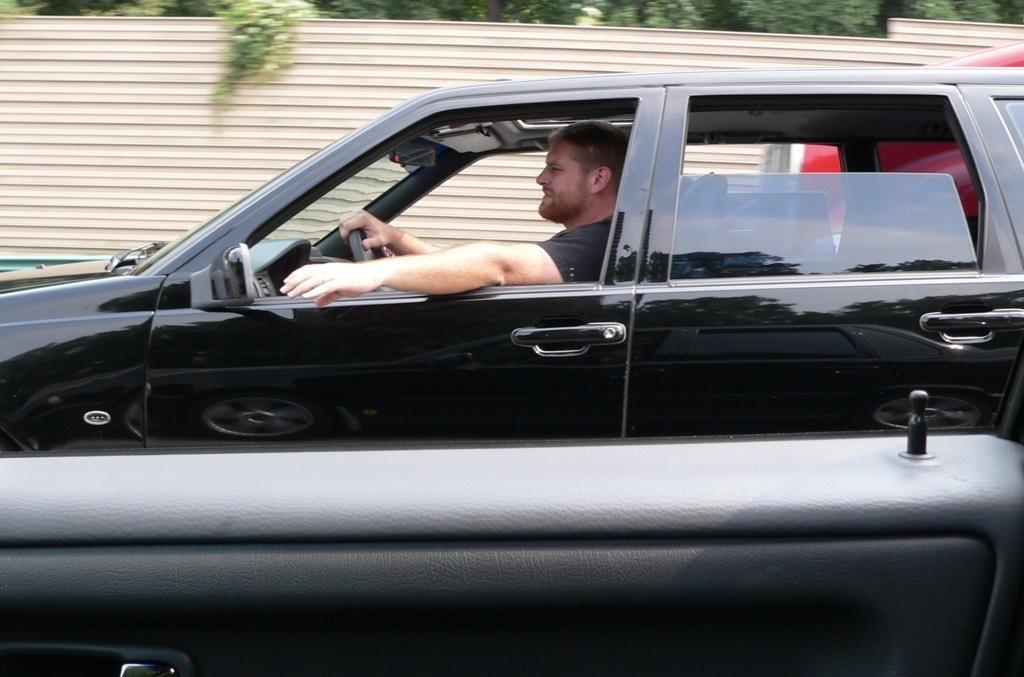Describe this image in one or two sentences. There is a man riding black color car beside him there is a fence and trees. 